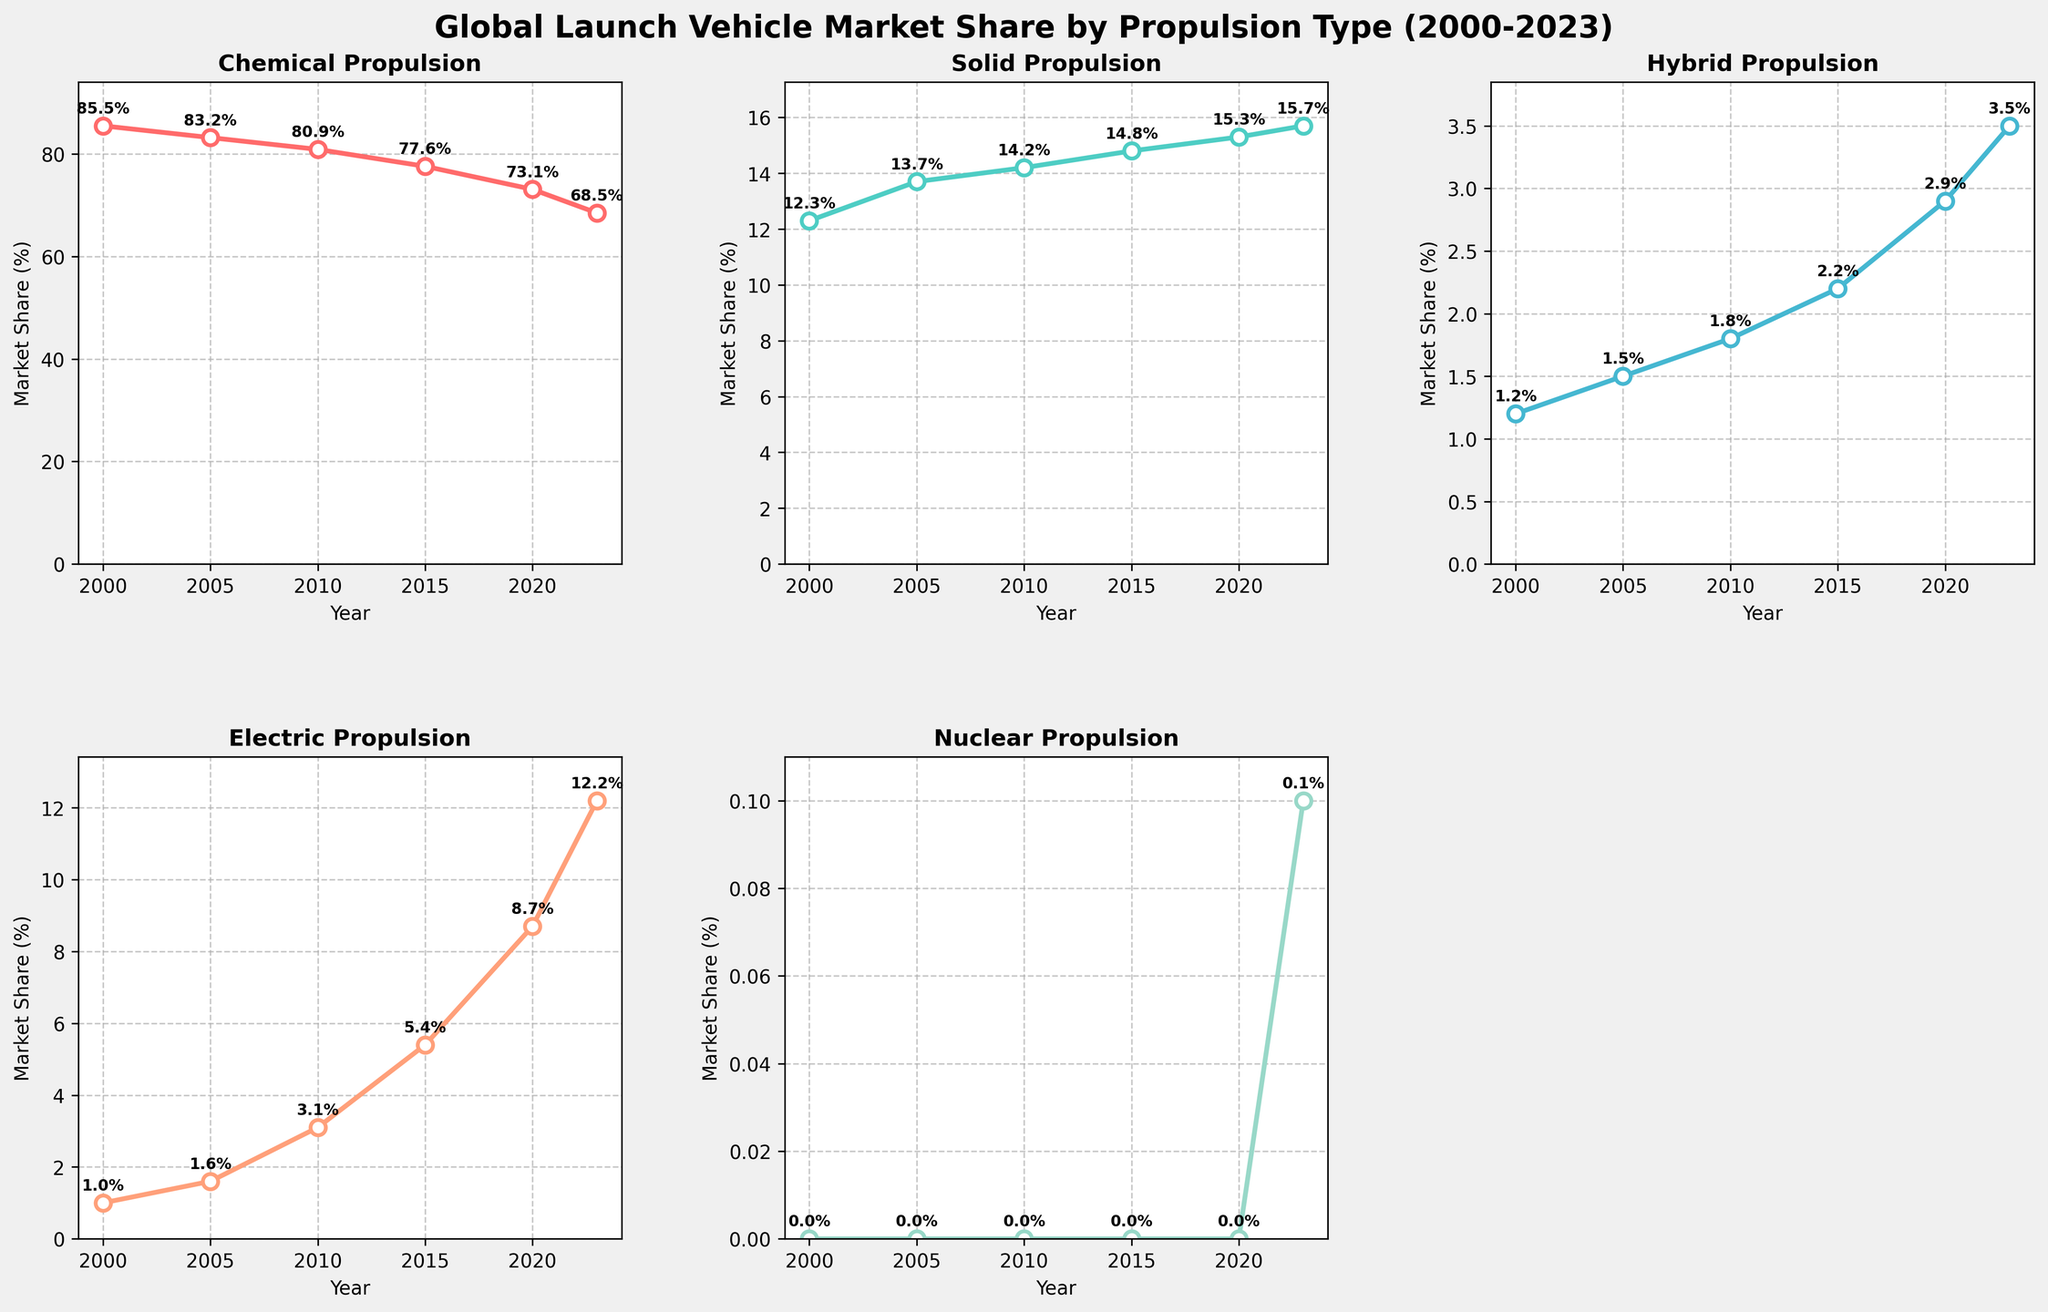What is the title of the figure? The title of the figure is shown at the top of the entire plot and reads "Global Launch Vehicle Market Share by Propulsion Type (2000-2023)".
Answer: Global Launch Vehicle Market Share by Propulsion Type (2000-2023) How many subplots are there and how are they arranged? There are five subplots arranged in a 2x3 grid, but one spot in the grid is empty. This makes a total of 5 subplots shown: Chemical, Solid, Hybrid, Electric, and Nuclear.
Answer: 5 Which subplot has experienced the highest growth in market share from 2000 to 2023? Comparing the starting percentage in 2000 and the ending percentage in 2023 for each subplot, the Electric propulsion subplot shows the highest growth, going from 1.0% to 12.2%.
Answer: Electric In which year did Hybrid propulsion surpass 2% market share? By looking at the Hybrid propulsion subplot, Hybrid propulsion surpassed a 2% market share in the year 2015.
Answer: 2015 What's the difference in the market share of Chemical propulsion between the years 2000 and 2023? The difference can be calculated by subtracting the market share in 2023 (68.5%) from the market share in 2000 (85.5%). So, 85.5% - 68.5% = 17%.
Answer: 17% What propulsion type has the lowest market share in 2023? The Nuclear propulsion subplot shows the lowest market share in 2023 at 0.1%.
Answer: Nuclear Which two propulsion types have shown a consistently upward trend from 2000 to 2023? By observing the plots, Electric and Solid propulsion types both show a consistently upward trend from 2000 to 2023.
Answer: Electric and Solid How many years did the Solid propulsion type market share increase consecutively from 2000 to 2023? Checking the data points for Solid propulsion in its respective subplot, its market share increased consecutively from 2000 (12.3%) to 2023 (15.7%), which is an increase over each of the 23 years.
Answer: 23 years In which year did Electric propulsion exceed a 10% market share? According to the Electric propulsion subplot, Electric propulsion exceeded a 10% market share in the year 2023.
Answer: 2023 